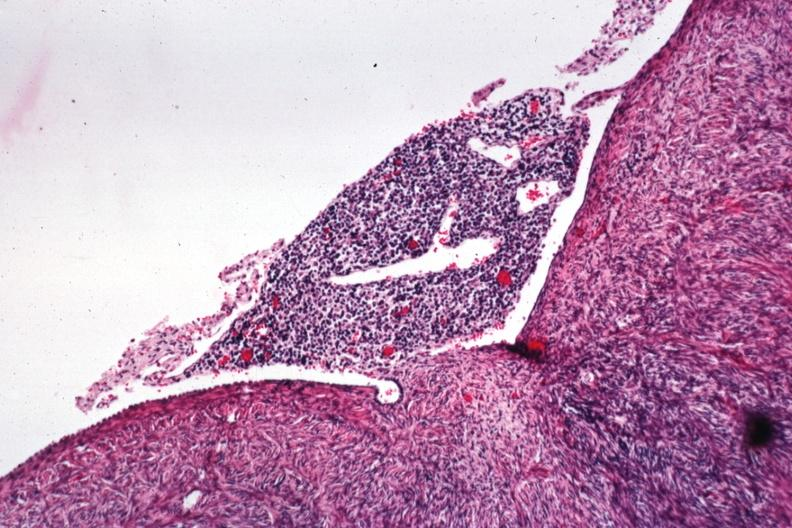what is present?
Answer the question using a single word or phrase. Ovary 